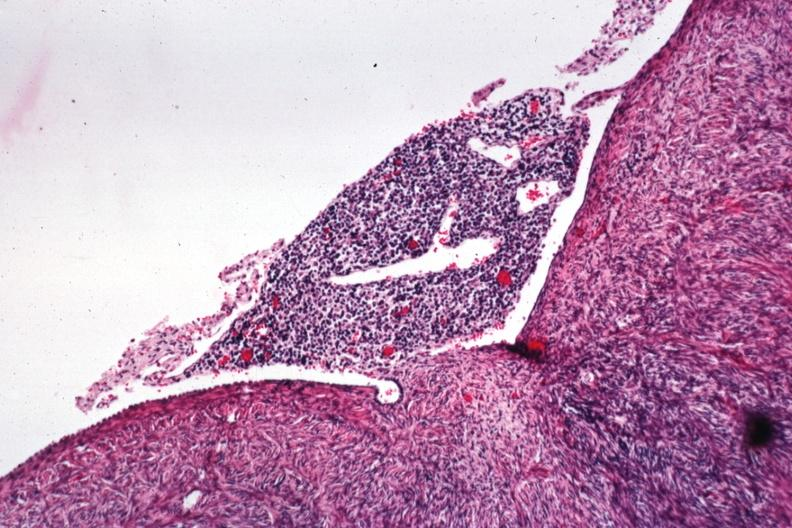what is present?
Answer the question using a single word or phrase. Ovary 